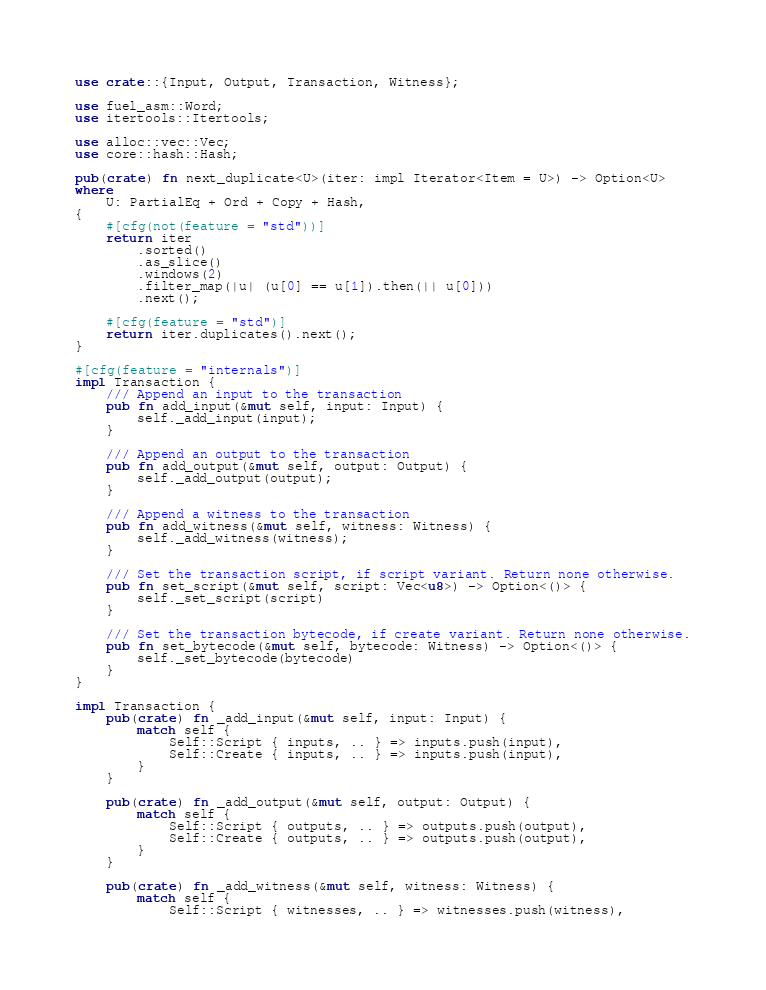<code> <loc_0><loc_0><loc_500><loc_500><_Rust_>use crate::{Input, Output, Transaction, Witness};

use fuel_asm::Word;
use itertools::Itertools;

use alloc::vec::Vec;
use core::hash::Hash;

pub(crate) fn next_duplicate<U>(iter: impl Iterator<Item = U>) -> Option<U>
where
    U: PartialEq + Ord + Copy + Hash,
{
    #[cfg(not(feature = "std"))]
    return iter
        .sorted()
        .as_slice()
        .windows(2)
        .filter_map(|u| (u[0] == u[1]).then(|| u[0]))
        .next();

    #[cfg(feature = "std")]
    return iter.duplicates().next();
}

#[cfg(feature = "internals")]
impl Transaction {
    /// Append an input to the transaction
    pub fn add_input(&mut self, input: Input) {
        self._add_input(input);
    }

    /// Append an output to the transaction
    pub fn add_output(&mut self, output: Output) {
        self._add_output(output);
    }

    /// Append a witness to the transaction
    pub fn add_witness(&mut self, witness: Witness) {
        self._add_witness(witness);
    }

    /// Set the transaction script, if script variant. Return none otherwise.
    pub fn set_script(&mut self, script: Vec<u8>) -> Option<()> {
        self._set_script(script)
    }

    /// Set the transaction bytecode, if create variant. Return none otherwise.
    pub fn set_bytecode(&mut self, bytecode: Witness) -> Option<()> {
        self._set_bytecode(bytecode)
    }
}

impl Transaction {
    pub(crate) fn _add_input(&mut self, input: Input) {
        match self {
            Self::Script { inputs, .. } => inputs.push(input),
            Self::Create { inputs, .. } => inputs.push(input),
        }
    }

    pub(crate) fn _add_output(&mut self, output: Output) {
        match self {
            Self::Script { outputs, .. } => outputs.push(output),
            Self::Create { outputs, .. } => outputs.push(output),
        }
    }

    pub(crate) fn _add_witness(&mut self, witness: Witness) {
        match self {
            Self::Script { witnesses, .. } => witnesses.push(witness),</code> 